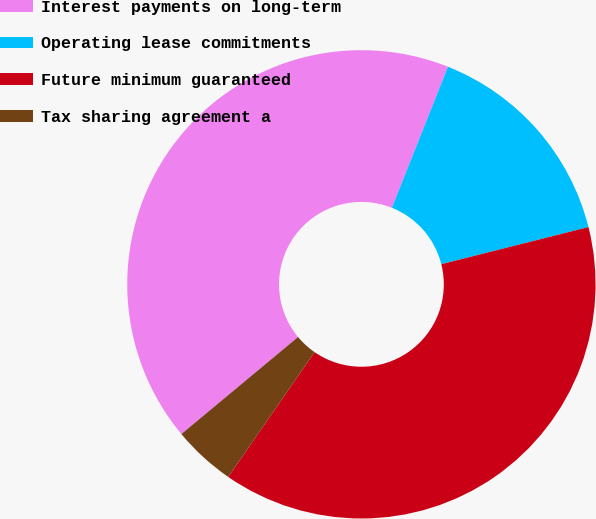Convert chart to OTSL. <chart><loc_0><loc_0><loc_500><loc_500><pie_chart><fcel>Interest payments on long-term<fcel>Operating lease commitments<fcel>Future minimum guaranteed<fcel>Tax sharing agreement a<nl><fcel>42.07%<fcel>15.04%<fcel>38.56%<fcel>4.33%<nl></chart> 